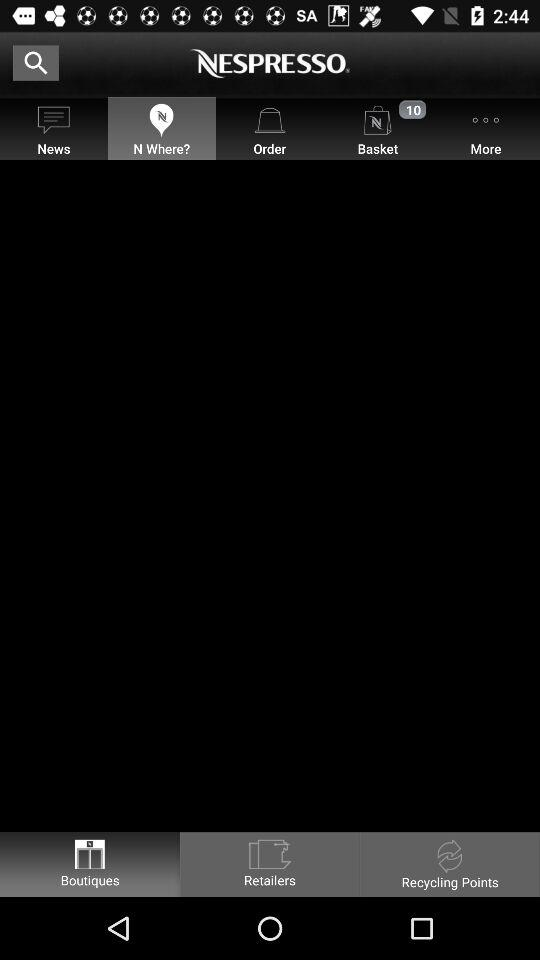How many new items are in the basket? There are 10 new items in the basket. 